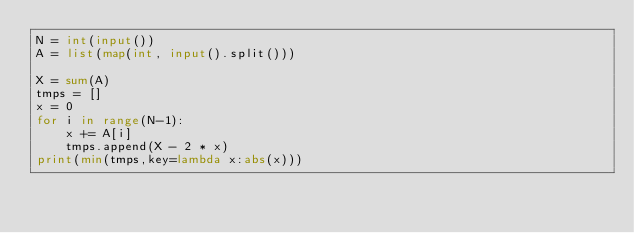<code> <loc_0><loc_0><loc_500><loc_500><_Python_>N = int(input())
A = list(map(int, input().split()))

X = sum(A)
tmps = []
x = 0
for i in range(N-1):
    x += A[i]
    tmps.append(X - 2 * x)
print(min(tmps,key=lambda x:abs(x)))
</code> 